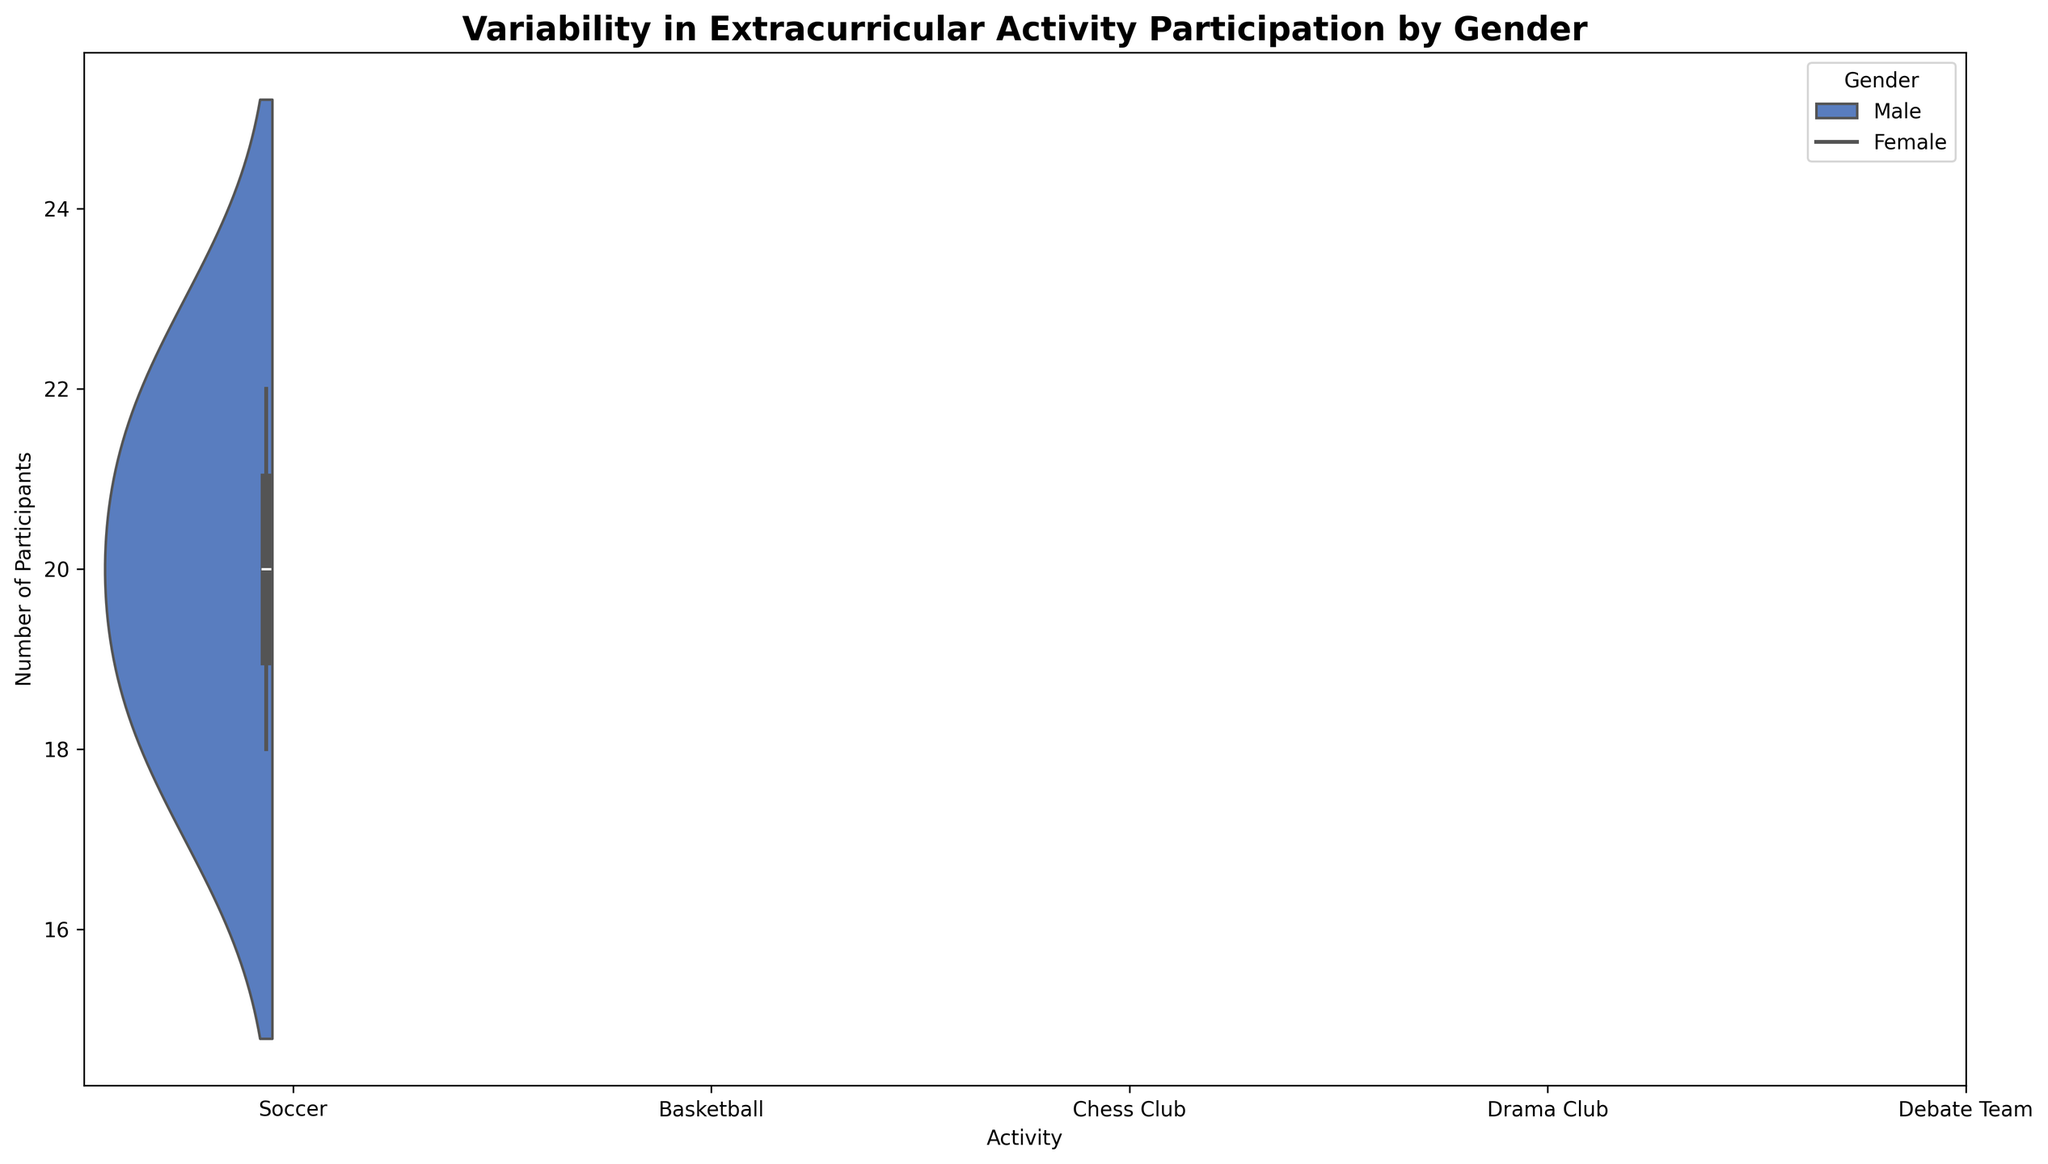What's the activity with the highest variability in male participants? To find this, look for the male dataset with the widest distribution in the violin plot. The wider the plot, the greater the variability. Drama Club has a range from 18 to 22, which appears to be the widest range for male participants.
Answer: Drama Club Which gender participates more in the Debate Team? Compare the center of the distributions for males and females in the Debate Team. The female distribution is higher, generally ranging from 18 to 22 participants, whereas the male distribution ranges from 9 to 11 participants.
Answer: Female What is the activity where both genders have a roughly equal number of participants? Check the overlaps of the distributions for both genders in each activity. The Drama Club shows good overlap between the number of male and female participants, with both genders having the same range of 18 to 22 for males and 48 to 52 for females.
Answer: Drama Club Which activity has the largest difference in participation between genders? Compare the median number of participants for both genders in each activity. Soccer shows a marked difference, with males typically participating around 40 while females participate around 30.
Answer: Soccer For Basketball, what is the range of female participants? Find the spread of the female distribution in the violin plot for Basketball. The range is from 23 to 27 participants.
Answer: 23 to 27 Which gender has more variability in the Chess Club? Compare the width of the distributions in the violin plot for males and females. Males range from 14 to 16 participants, while females range from 9 to 11 participants. The female distribution is wider.
Answer: Female Is there an activity where female participation extends beyond the male participation range? Look for activities where the distribution of female participants goes beyond the male participants. In Drama Club, females range from 48 to 52 while males range from 18 to 22, showing a much higher and broader range.
Answer: Drama Club What can be said about the median number of male participants in Soccer compared to the median number of female participants in Soccer? The median is the central line of the distribution. For males, it’s around 40, while for females it is lower, around 30.
Answer: Higher In which activity are male and female medians the closest? Compare the central points (medians) of both genders for each activity. In the Chess Club, both medians are very close, males at 15 and females at 10.
Answer: Chess Club For Chess Club, which gender has a more condensed range of participant numbers? Look at the spread of the violin plots for both genders in the Chess Club. The male range is from 14 to 16, while the female range is from 9 to 11. The male range is narrower, thus more condensed.
Answer: Male 